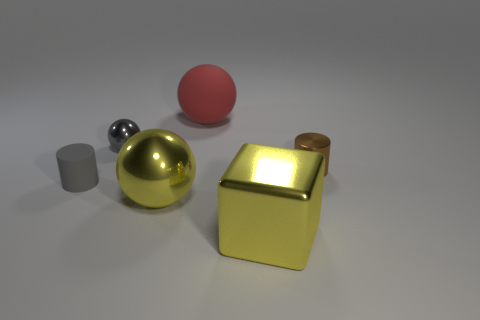What is the small brown thing made of?
Ensure brevity in your answer.  Metal. What number of things are either big cyan things or large cubes?
Offer a very short reply. 1. There is a yellow object on the left side of the big red object; how big is it?
Make the answer very short. Large. What number of other objects are there of the same material as the big yellow block?
Your response must be concise. 3. There is a big object behind the tiny sphere; is there a yellow sphere that is on the right side of it?
Provide a short and direct response. No. Is there any other thing that has the same shape as the brown object?
Offer a very short reply. Yes. What is the color of the other thing that is the same shape as the tiny gray matte thing?
Your answer should be very brief. Brown. The gray matte thing has what size?
Make the answer very short. Small. Are there fewer red matte things in front of the big red rubber ball than tiny red metal objects?
Provide a short and direct response. No. Is the material of the tiny gray cylinder the same as the gray object behind the tiny brown thing?
Your answer should be very brief. No. 